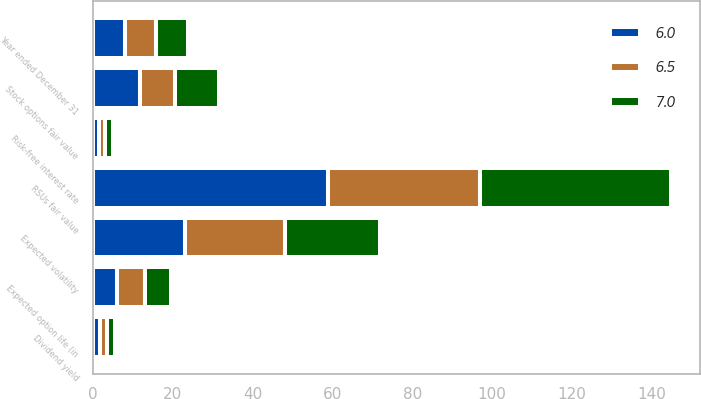<chart> <loc_0><loc_0><loc_500><loc_500><stacked_bar_chart><ecel><fcel>Year ended December 31<fcel>RSUs fair value<fcel>Stock options fair value<fcel>Dividend yield<fcel>Expected volatility<fcel>Risk-free interest rate<fcel>Expected option life (in<nl><fcel>6<fcel>7.9<fcel>58.81<fcel>11.78<fcel>1.7<fcel>23<fcel>1.6<fcel>6<nl><fcel>7<fcel>7.9<fcel>47.91<fcel>11.11<fcel>1.8<fcel>24<fcel>2.2<fcel>6.5<nl><fcel>6.5<fcel>7.9<fcel>38.28<fcel>8.8<fcel>1.9<fcel>25<fcel>1.3<fcel>7<nl></chart> 